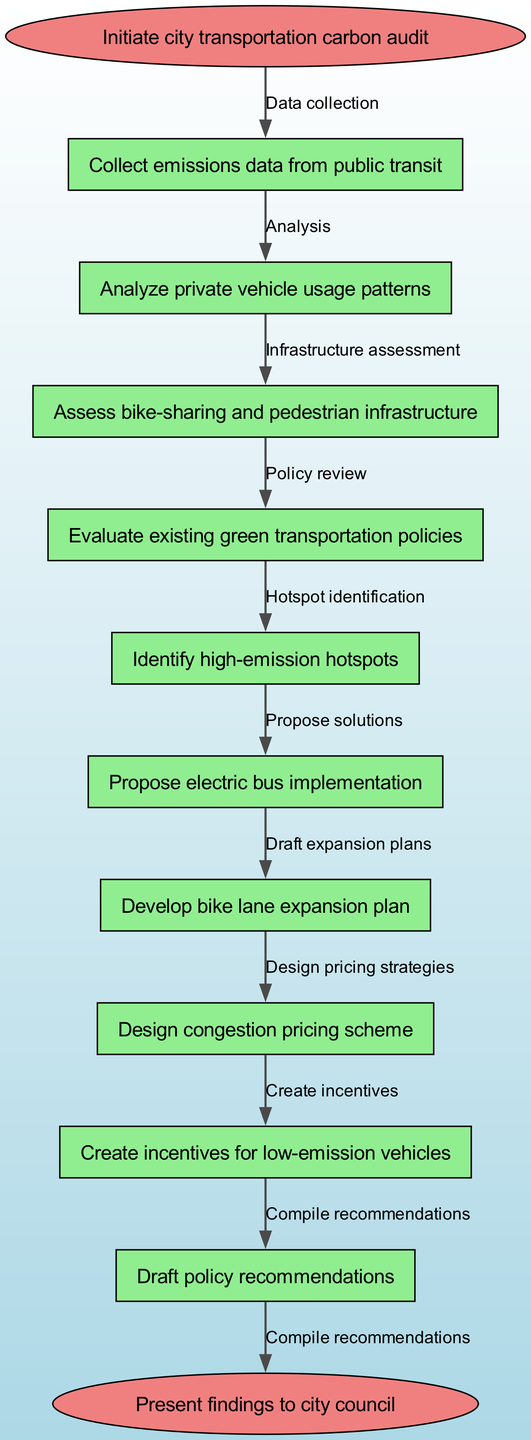What is the starting point of the protocol? The starting point of the protocol is indicated by the 'start' node, which specifies "Initiate city transportation carbon audit."
Answer: Initiate city transportation carbon audit How many nodes are present in the diagram? The diagram lists 10 nodes, including the start and end nodes, which contribute to the overall carbon reduction protocol.
Answer: 10 What action follows after collecting emissions data from public transit? According to the flow of the diagram, the next action after collecting emissions data is to "Analyze private vehicle usage patterns."
Answer: Analyze private vehicle usage patterns What is the end point of the protocol? The end point is defined as the 'end' node, which states, "Present findings to city council."
Answer: Present findings to city council Which node is linked to the "Draft policy recommendations" action? The "Draft policy recommendations" action is connected to the last node prior to the end node in the protocol sequence. It is the result of combining all previous efforts in the pathway.
Answer: Draft policy recommendations What type of analysis is conducted immediately after assessing bike-sharing and pedestrian infrastructure? The protocol indicates that after assessing bike-sharing and pedestrian infrastructure, the next step is to "Evaluate existing green transportation policies."
Answer: Evaluate existing green transportation policies How many actions are involved in the data collection phase? The data collection phase involves collecting emissions data from public transit, which is the only action indicated before the analysis and assessment phases commence.
Answer: 1 Which action precedes the design of congestion pricing scheme? The action that comes right before the design of the congestion pricing scheme is to "Propose electric bus implementation."
Answer: Propose electric bus implementation What is the purpose of identifying high-emission hotspots? The identification of high-emission hotspots serves to highlight critical areas that need targeted interventions, making it crucial for proposing subsequent actions.
Answer: Highlight critical areas What role do incentives for low-emission vehicles serve in the overall protocol? The creation of incentives for low-emission vehicles acts as a proposed solution within the protocol, aimed at encouraging shift towards greener transportation alternatives.
Answer: Encourage shift towards greener transportation alternatives 